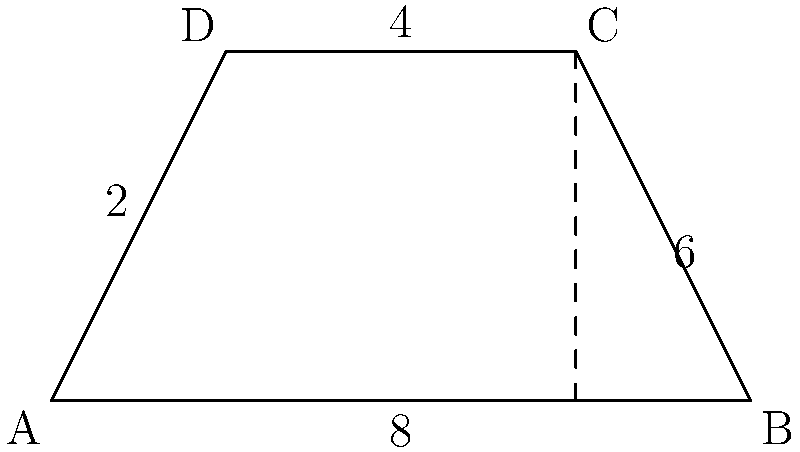As a long-time blogger, you're creating a post to help newcomers understand geometric concepts. You decide to use a trapezoid-shaped blog layout as an example. The layout has parallel sides of 8 units and 4 units, with non-parallel sides of 2 units and 6 units. What is the area of this trapezoid-shaped layout? Let's approach this step-by-step:

1) First, recall the formula for the area of a trapezoid:
   $$ A = \frac{1}{2}(b_1 + b_2)h $$
   where $A$ is the area, $b_1$ and $b_2$ are the lengths of the parallel sides, and $h$ is the height.

2) We know the parallel sides: $b_1 = 8$ and $b_2 = 4$.

3) We need to find the height $h$. We can do this using the Pythagorean theorem.

4) The difference between the parallel sides is $8 - 4 = 4$. Half of this (2) is the base of a right triangle formed by the height and one of the non-parallel sides.

5) Let's use the shorter non-parallel side (2 units). We have a right triangle where:
   - The hypotenuse is 2
   - One side (half the difference of parallel sides) is 2

6) Using the Pythagorean theorem:
   $$ h^2 + 2^2 = 2^2 $$
   $$ h^2 = 4 - 4 = 0 $$
   $$ h = 0 $$

7) This result (h = 0) is incorrect and doesn't make sense for our trapezoid. Let's use the longer non-parallel side (6 units) instead:
   $$ h^2 + 2^2 = 6^2 $$
   $$ h^2 = 36 - 4 = 32 $$
   $$ h = \sqrt{32} = 4\sqrt{2} $$

8) Now we can calculate the area:
   $$ A = \frac{1}{2}(8 + 4)(4\sqrt{2}) = 6(4\sqrt{2}) = 24\sqrt{2} $$

Therefore, the area of the trapezoid-shaped layout is $24\sqrt{2}$ square units.
Answer: $24\sqrt{2}$ square units 